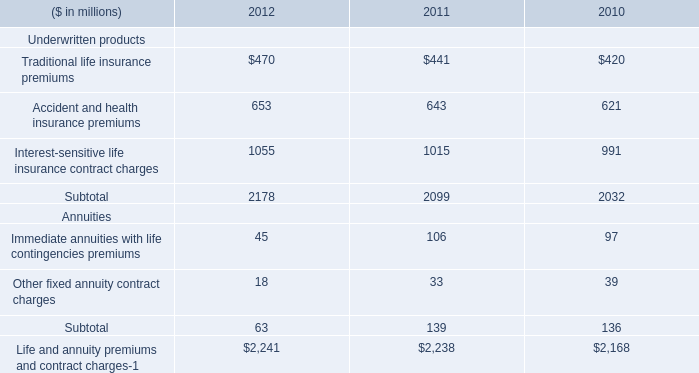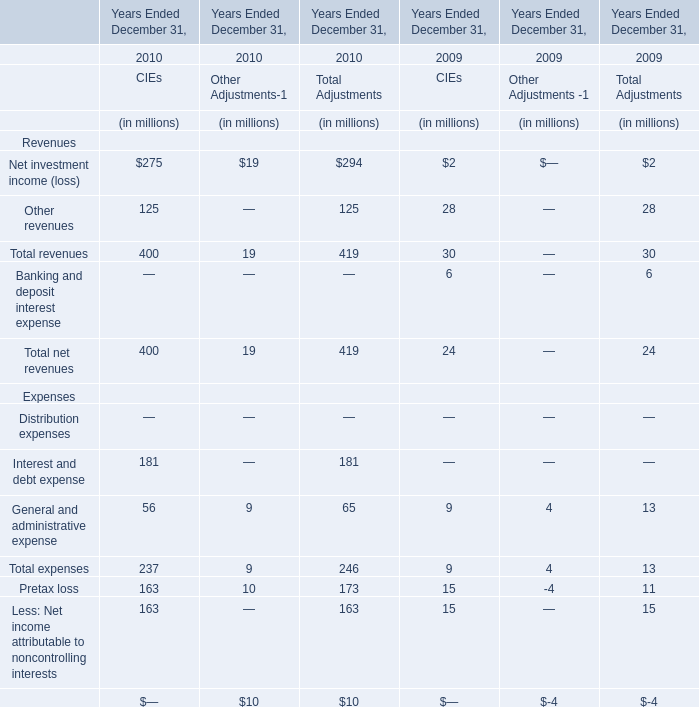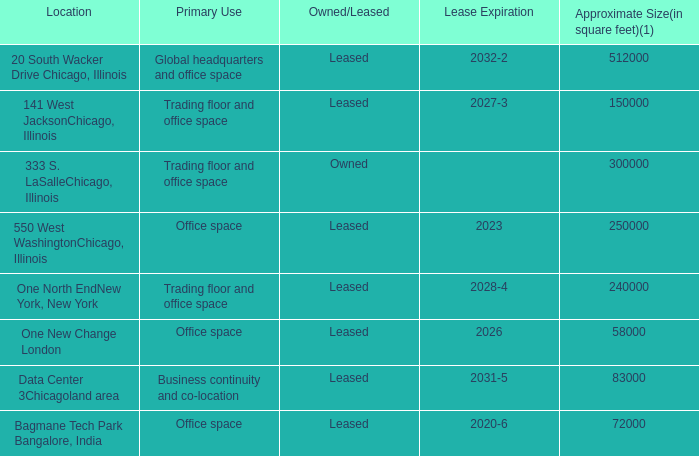What will Total revenues of CIEs reach in 2011 if it continues to grow at its current rate? (in dollars in millions) 
Computations: (400 * (1 + ((400 - 30) / 30)))
Answer: 5333.33333. 